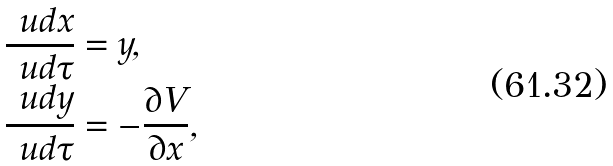<formula> <loc_0><loc_0><loc_500><loc_500>\frac { \ u d x } { \ u d \tau } & = y , \\ \frac { \ u d y } { \ u d \tau } & = - \frac { \partial V } { \partial x } ,</formula> 